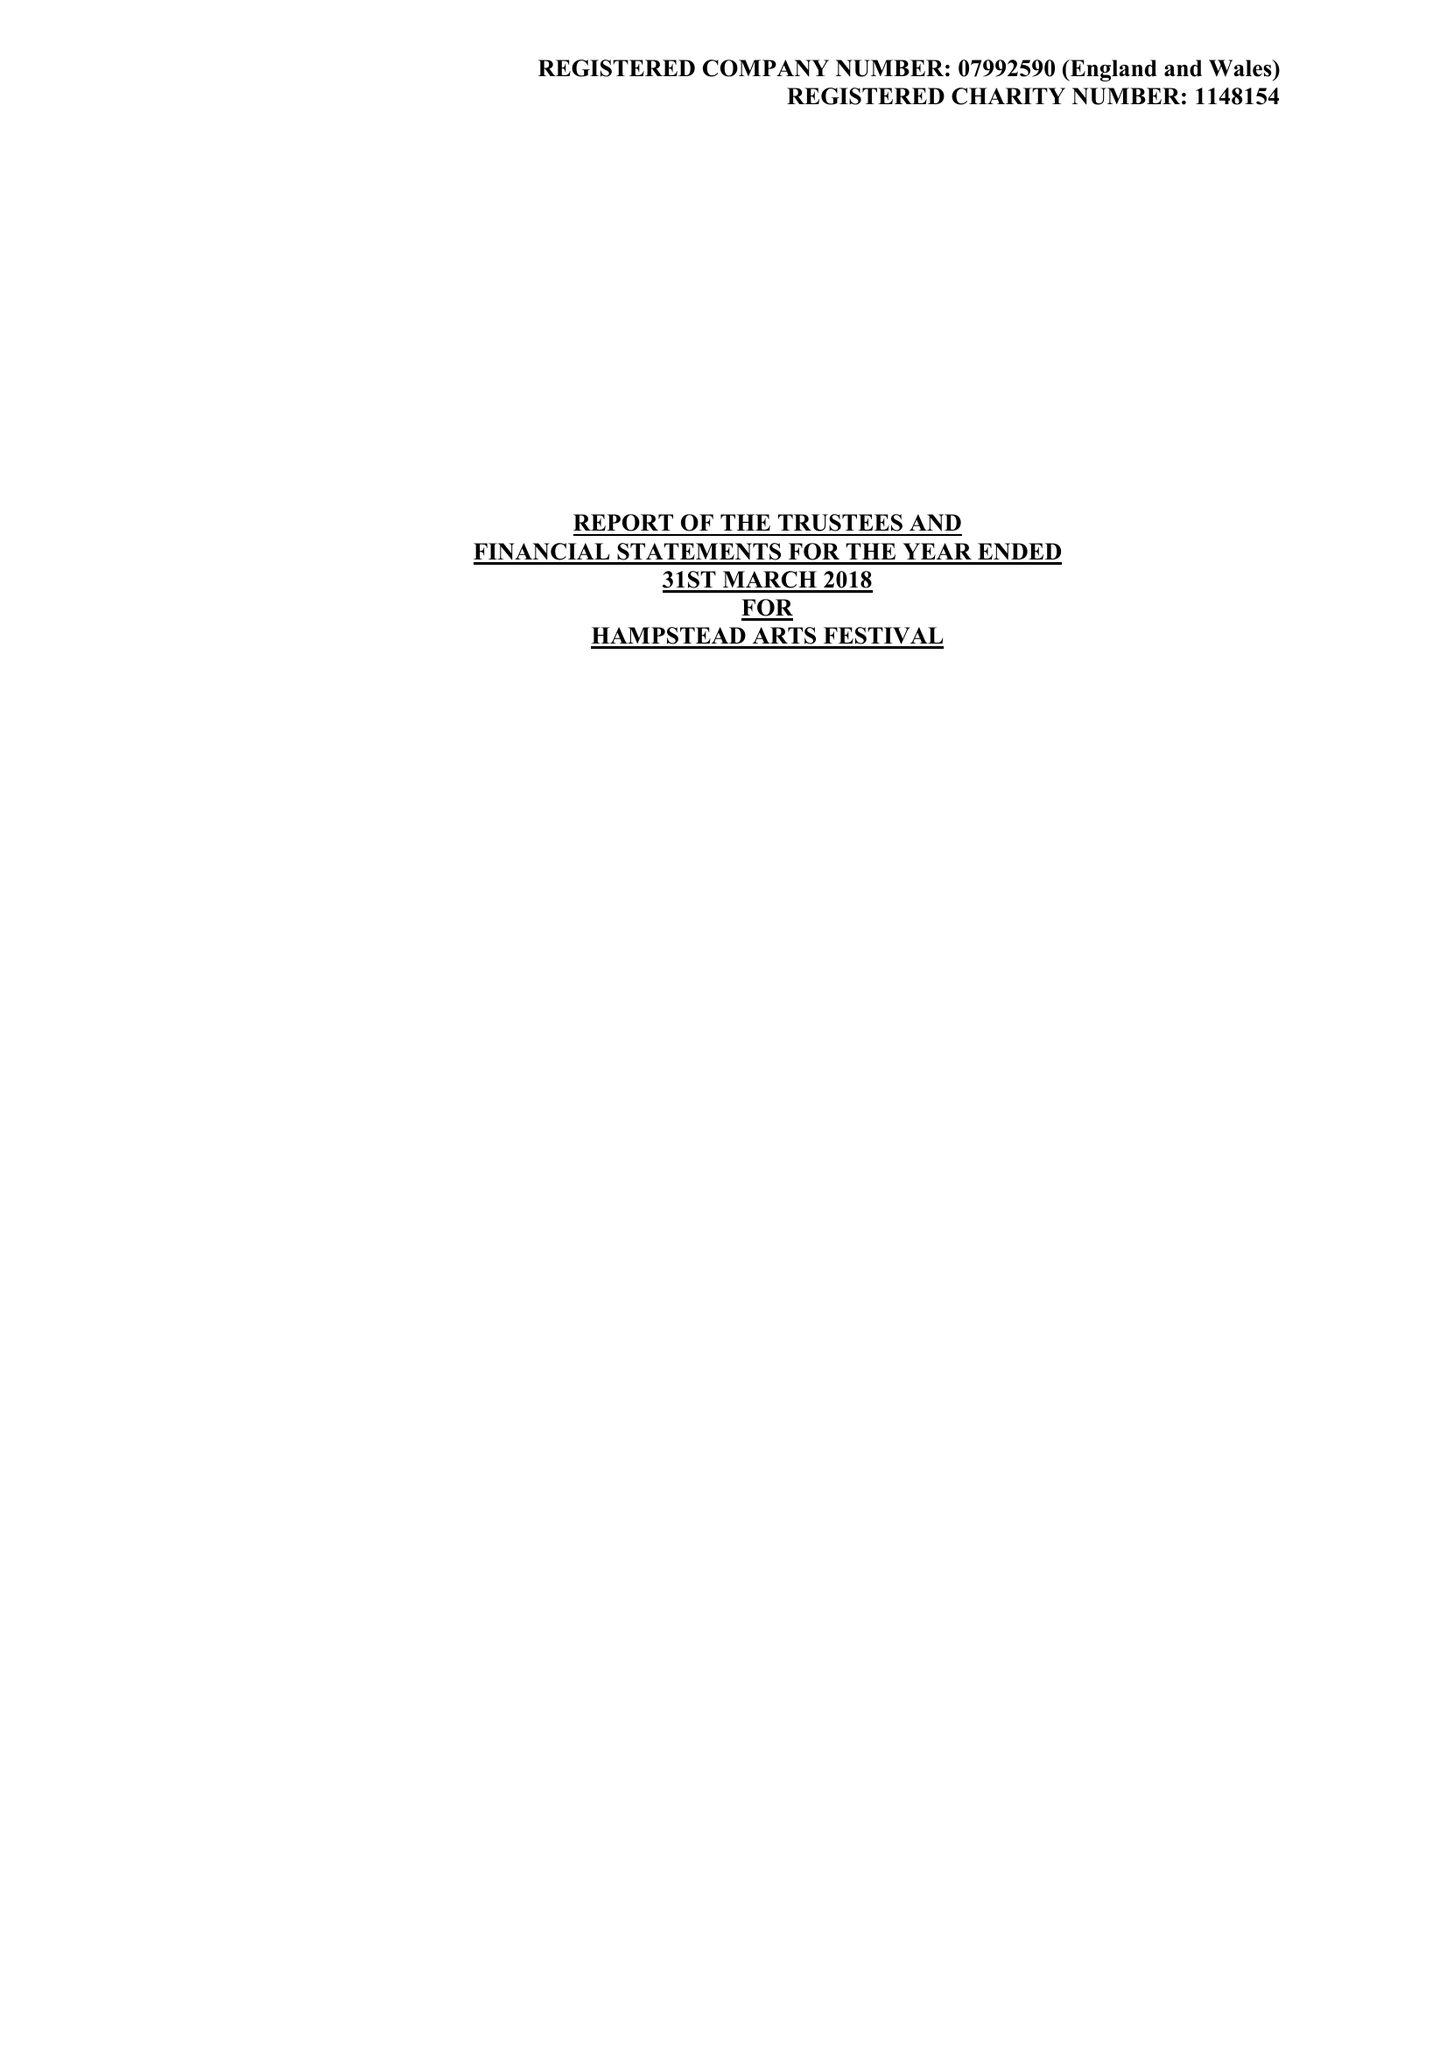What is the value for the report_date?
Answer the question using a single word or phrase. 2018-03-31 